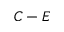<formula> <loc_0><loc_0><loc_500><loc_500>C - E</formula> 